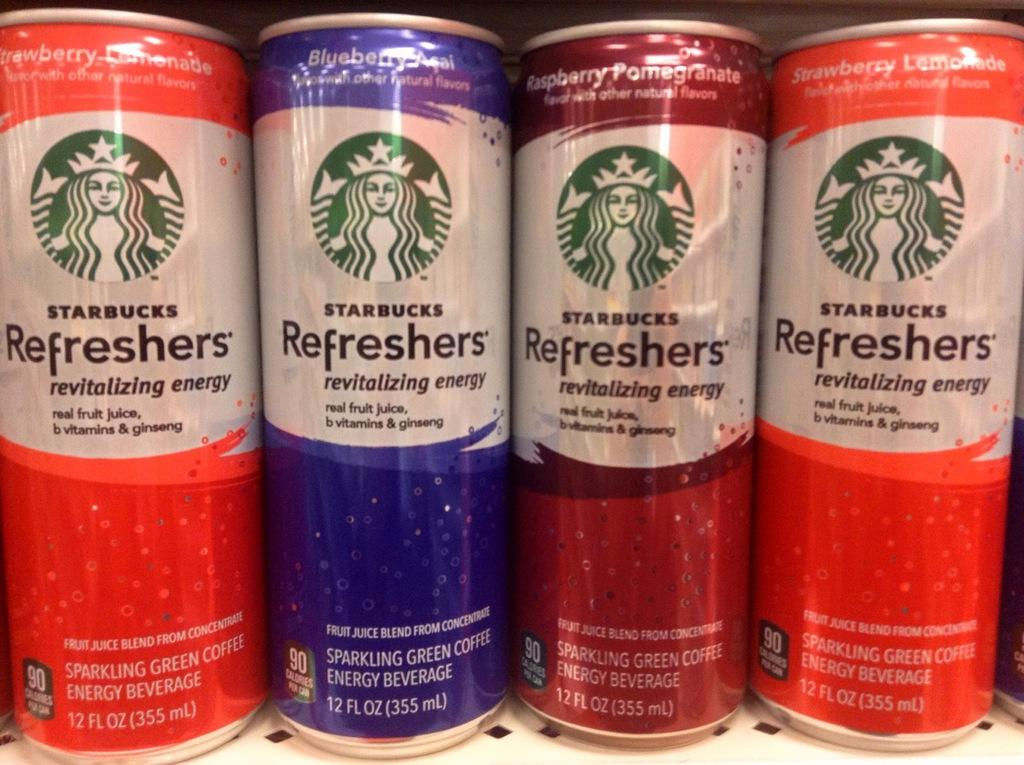<image>
Share a concise interpretation of the image provided. A row of cans of Starbucks beverages in different flavors. 